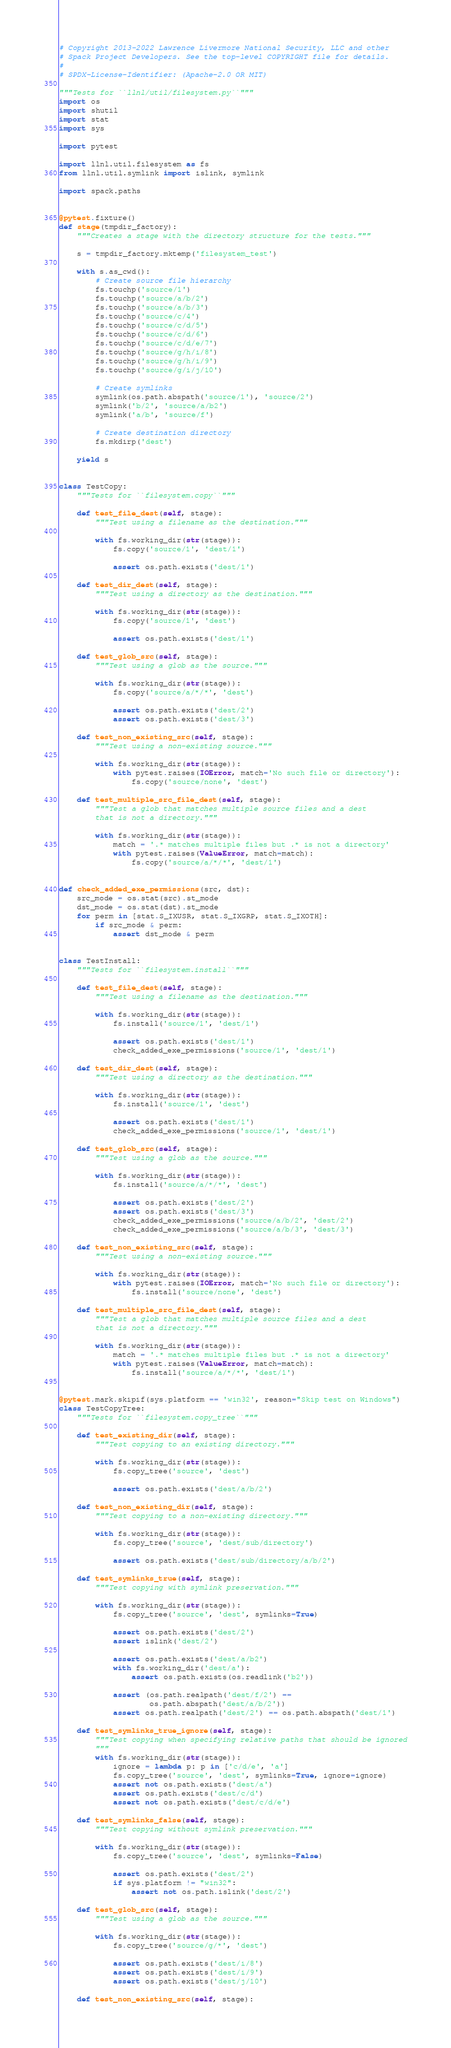Convert code to text. <code><loc_0><loc_0><loc_500><loc_500><_Python_># Copyright 2013-2022 Lawrence Livermore National Security, LLC and other
# Spack Project Developers. See the top-level COPYRIGHT file for details.
#
# SPDX-License-Identifier: (Apache-2.0 OR MIT)

"""Tests for ``llnl/util/filesystem.py``"""
import os
import shutil
import stat
import sys

import pytest

import llnl.util.filesystem as fs
from llnl.util.symlink import islink, symlink

import spack.paths


@pytest.fixture()
def stage(tmpdir_factory):
    """Creates a stage with the directory structure for the tests."""

    s = tmpdir_factory.mktemp('filesystem_test')

    with s.as_cwd():
        # Create source file hierarchy
        fs.touchp('source/1')
        fs.touchp('source/a/b/2')
        fs.touchp('source/a/b/3')
        fs.touchp('source/c/4')
        fs.touchp('source/c/d/5')
        fs.touchp('source/c/d/6')
        fs.touchp('source/c/d/e/7')
        fs.touchp('source/g/h/i/8')
        fs.touchp('source/g/h/i/9')
        fs.touchp('source/g/i/j/10')

        # Create symlinks
        symlink(os.path.abspath('source/1'), 'source/2')
        symlink('b/2', 'source/a/b2')
        symlink('a/b', 'source/f')

        # Create destination directory
        fs.mkdirp('dest')

    yield s


class TestCopy:
    """Tests for ``filesystem.copy``"""

    def test_file_dest(self, stage):
        """Test using a filename as the destination."""

        with fs.working_dir(str(stage)):
            fs.copy('source/1', 'dest/1')

            assert os.path.exists('dest/1')

    def test_dir_dest(self, stage):
        """Test using a directory as the destination."""

        with fs.working_dir(str(stage)):
            fs.copy('source/1', 'dest')

            assert os.path.exists('dest/1')

    def test_glob_src(self, stage):
        """Test using a glob as the source."""

        with fs.working_dir(str(stage)):
            fs.copy('source/a/*/*', 'dest')

            assert os.path.exists('dest/2')
            assert os.path.exists('dest/3')

    def test_non_existing_src(self, stage):
        """Test using a non-existing source."""

        with fs.working_dir(str(stage)):
            with pytest.raises(IOError, match='No such file or directory'):
                fs.copy('source/none', 'dest')

    def test_multiple_src_file_dest(self, stage):
        """Test a glob that matches multiple source files and a dest
        that is not a directory."""

        with fs.working_dir(str(stage)):
            match = '.* matches multiple files but .* is not a directory'
            with pytest.raises(ValueError, match=match):
                fs.copy('source/a/*/*', 'dest/1')


def check_added_exe_permissions(src, dst):
    src_mode = os.stat(src).st_mode
    dst_mode = os.stat(dst).st_mode
    for perm in [stat.S_IXUSR, stat.S_IXGRP, stat.S_IXOTH]:
        if src_mode & perm:
            assert dst_mode & perm


class TestInstall:
    """Tests for ``filesystem.install``"""

    def test_file_dest(self, stage):
        """Test using a filename as the destination."""

        with fs.working_dir(str(stage)):
            fs.install('source/1', 'dest/1')

            assert os.path.exists('dest/1')
            check_added_exe_permissions('source/1', 'dest/1')

    def test_dir_dest(self, stage):
        """Test using a directory as the destination."""

        with fs.working_dir(str(stage)):
            fs.install('source/1', 'dest')

            assert os.path.exists('dest/1')
            check_added_exe_permissions('source/1', 'dest/1')

    def test_glob_src(self, stage):
        """Test using a glob as the source."""

        with fs.working_dir(str(stage)):
            fs.install('source/a/*/*', 'dest')

            assert os.path.exists('dest/2')
            assert os.path.exists('dest/3')
            check_added_exe_permissions('source/a/b/2', 'dest/2')
            check_added_exe_permissions('source/a/b/3', 'dest/3')

    def test_non_existing_src(self, stage):
        """Test using a non-existing source."""

        with fs.working_dir(str(stage)):
            with pytest.raises(IOError, match='No such file or directory'):
                fs.install('source/none', 'dest')

    def test_multiple_src_file_dest(self, stage):
        """Test a glob that matches multiple source files and a dest
        that is not a directory."""

        with fs.working_dir(str(stage)):
            match = '.* matches multiple files but .* is not a directory'
            with pytest.raises(ValueError, match=match):
                fs.install('source/a/*/*', 'dest/1')


@pytest.mark.skipif(sys.platform == 'win32', reason="Skip test on Windows")
class TestCopyTree:
    """Tests for ``filesystem.copy_tree``"""

    def test_existing_dir(self, stage):
        """Test copying to an existing directory."""

        with fs.working_dir(str(stage)):
            fs.copy_tree('source', 'dest')

            assert os.path.exists('dest/a/b/2')

    def test_non_existing_dir(self, stage):
        """Test copying to a non-existing directory."""

        with fs.working_dir(str(stage)):
            fs.copy_tree('source', 'dest/sub/directory')

            assert os.path.exists('dest/sub/directory/a/b/2')

    def test_symlinks_true(self, stage):
        """Test copying with symlink preservation."""

        with fs.working_dir(str(stage)):
            fs.copy_tree('source', 'dest', symlinks=True)

            assert os.path.exists('dest/2')
            assert islink('dest/2')

            assert os.path.exists('dest/a/b2')
            with fs.working_dir('dest/a'):
                assert os.path.exists(os.readlink('b2'))

            assert (os.path.realpath('dest/f/2') ==
                    os.path.abspath('dest/a/b/2'))
            assert os.path.realpath('dest/2') == os.path.abspath('dest/1')

    def test_symlinks_true_ignore(self, stage):
        """Test copying when specifying relative paths that should be ignored
        """
        with fs.working_dir(str(stage)):
            ignore = lambda p: p in ['c/d/e', 'a']
            fs.copy_tree('source', 'dest', symlinks=True, ignore=ignore)
            assert not os.path.exists('dest/a')
            assert os.path.exists('dest/c/d')
            assert not os.path.exists('dest/c/d/e')

    def test_symlinks_false(self, stage):
        """Test copying without symlink preservation."""

        with fs.working_dir(str(stage)):
            fs.copy_tree('source', 'dest', symlinks=False)

            assert os.path.exists('dest/2')
            if sys.platform != "win32":
                assert not os.path.islink('dest/2')

    def test_glob_src(self, stage):
        """Test using a glob as the source."""

        with fs.working_dir(str(stage)):
            fs.copy_tree('source/g/*', 'dest')

            assert os.path.exists('dest/i/8')
            assert os.path.exists('dest/i/9')
            assert os.path.exists('dest/j/10')

    def test_non_existing_src(self, stage):</code> 